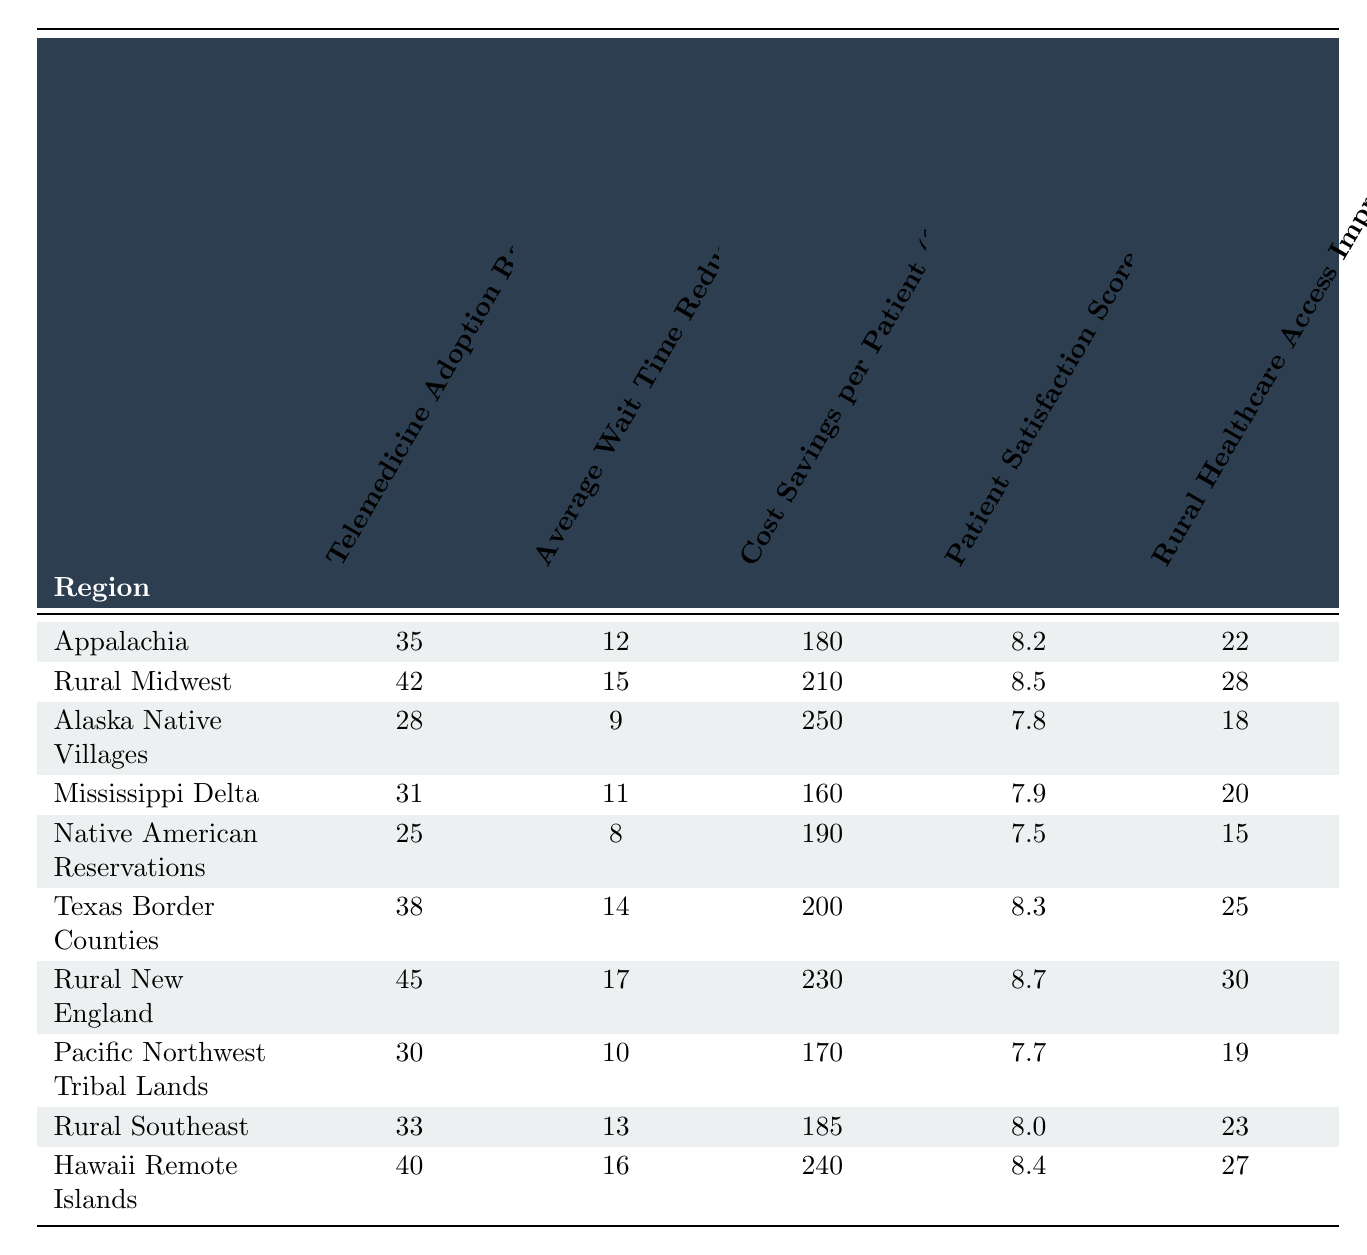What's the telemedicine adoption rate in Rural Midwest? The table shows that the telemedicine adoption rate in Rural Midwest is 42%.
Answer: 42% Which region has the highest average patient satisfaction score? Analyzing the Patient Satisfaction Score column, Rural New England has the highest score of 8.7.
Answer: 8.7 What is the average cost savings per patient across all regions? Adding up all the cost savings values: 180 + 210 + 250 + 160 + 190 + 200 + 230 + 170 + 185 + 240 = 1,975. There are 10 regions, so the average cost savings per patient is 1,975 / 10 = 197.5.
Answer: 197.5 Is the telemedicine adoption rate in Alaska Native Villages higher than the average for all regions? The average telemedicine adoption rate across all regions is (35 + 42 + 28 + 31 + 25 + 38 + 45 + 30 + 33 + 40) / 10 = 36.3. Since 28 is less than 36.3, the adoption rate in Alaska Native Villages is lower.
Answer: No What is the difference in average wait time reduction between Rural New England and the Mississippi Delta? First, find the average wait times: Rural New England has 17 days and the Mississippi Delta has 11 days. The difference is 17 - 11 = 6 days.
Answer: 6 days Which region offers the highest cost savings per patient, and what is that amount? Upon checking the Cost Savings per Patient column, Alaska Native Villages shows the highest cost savings at 250.
Answer: 250 What is the relationship between telemedicine adoption rate and patient satisfaction score in the Texas Border Counties? The telemedicine adoption rate is 38% and the patient satisfaction score is 8.3. This indicates that higher telemedicine adoption might correlate with higher patient satisfaction, although this is a single case.
Answer: Correlational suggestion Calculate the average rural healthcare access improvement across all regions. Summing the Rural Healthcare Access Improvement values gives 22 + 28 + 18 + 20 + 15 + 25 + 30 + 19 + 23 + 27 = 207. The average is 207 / 10 = 20.7.
Answer: 20.7 Is it true that more than half of the regions have a telemedicine adoption rate of 30% or lower? The regions with a telemedicine adoption rate of 30% or lower are Alaska Native Villages (28), Native American Reservations (25), and Mississippi Delta (31). This totals to 3 out of 10 regions, which is not more than half.
Answer: No Which two regions have the lowest wait time reduction, and what are their values? The lowest wait time reductions are in Alaska Native Villages (9 days) and Native American Reservations (8 days).
Answer: Alaska Native Villages (9 days), Native American Reservations (8 days) 